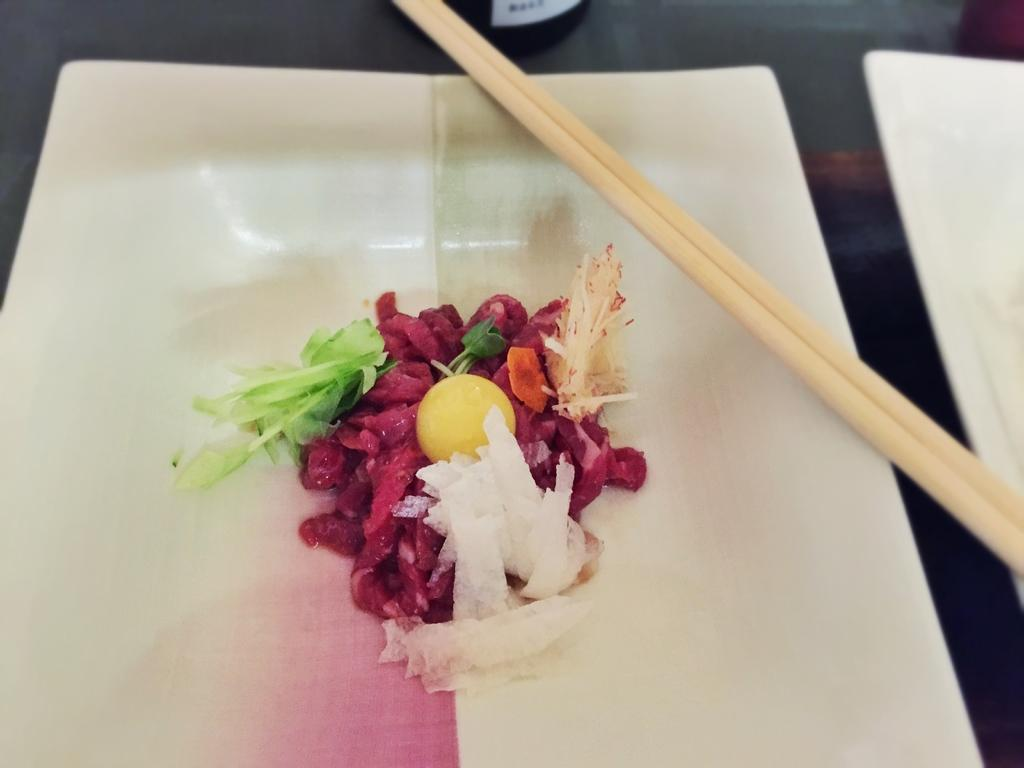What type of food is in the image? There is a salad in the image. How is the salad presented? The salad is in a plate. What utensils are visible in the image? There are two chopsticks in the image. Where are the chopsticks located? The chopsticks are on a table. How many snakes are slithering on the table in the image? There are no snakes present in the image; it features a salad in a plate and chopsticks on a table. What caused the salad to fall off the table in the image? There is no indication in the image that the salad has fallen off the table, and no cause for such an event is mentioned. 